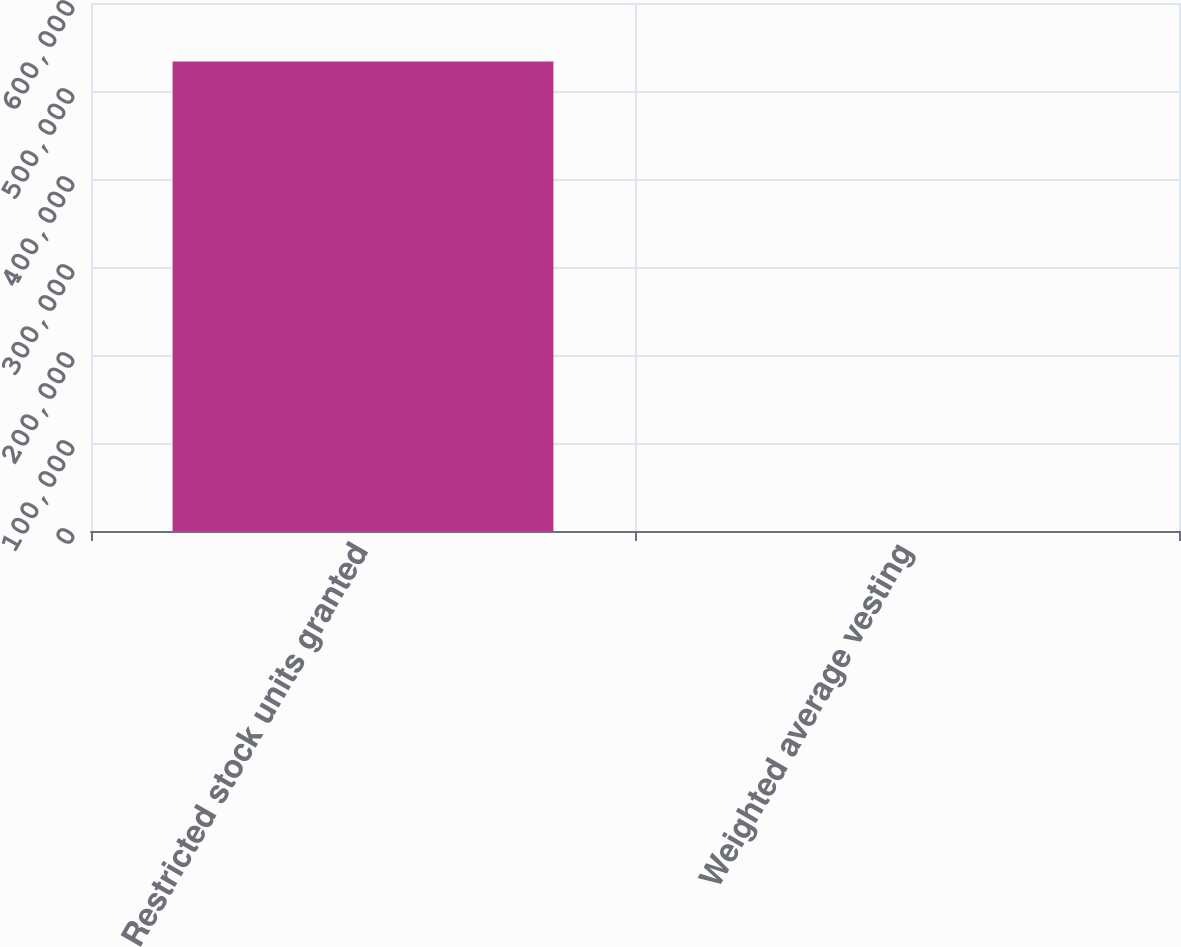Convert chart. <chart><loc_0><loc_0><loc_500><loc_500><bar_chart><fcel>Restricted stock units granted<fcel>Weighted average vesting<nl><fcel>533399<fcel>3<nl></chart> 